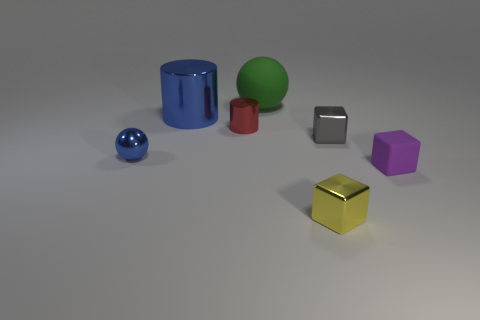Add 2 yellow blocks. How many objects exist? 9 Subtract all cylinders. How many objects are left? 5 Add 2 yellow metallic objects. How many yellow metallic objects exist? 3 Subtract 0 brown blocks. How many objects are left? 7 Subtract all large purple metallic balls. Subtract all blue cylinders. How many objects are left? 6 Add 6 metal spheres. How many metal spheres are left? 7 